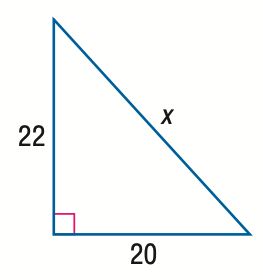Answer the mathemtical geometry problem and directly provide the correct option letter.
Question: Find x.
Choices: A: 2 \sqrt { 21 } B: 20 \sqrt { 2 } C: 2 \sqrt { 221 } D: 22 \sqrt { 2 } C 